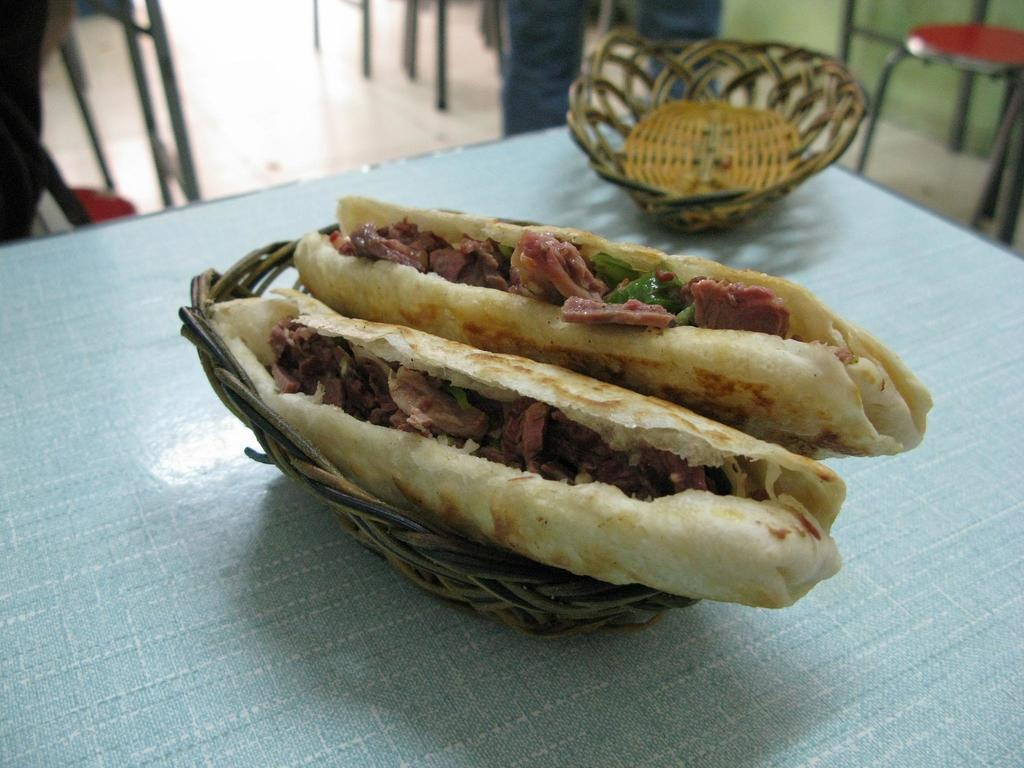What type of food is in the basket in the image? There are two sandwiches in a basket in the image. What else can be seen on the table in the image? There is another basket on the table in the image. What can be seen in the background of the image? Chairs are visible in the background of the image. Are there any people present in the image? Yes, there is a person in the background of the image. What type of cork can be seen on the street in the image? There is no cork or street present in the image; it features sandwiches in a basket and other items on a table. 